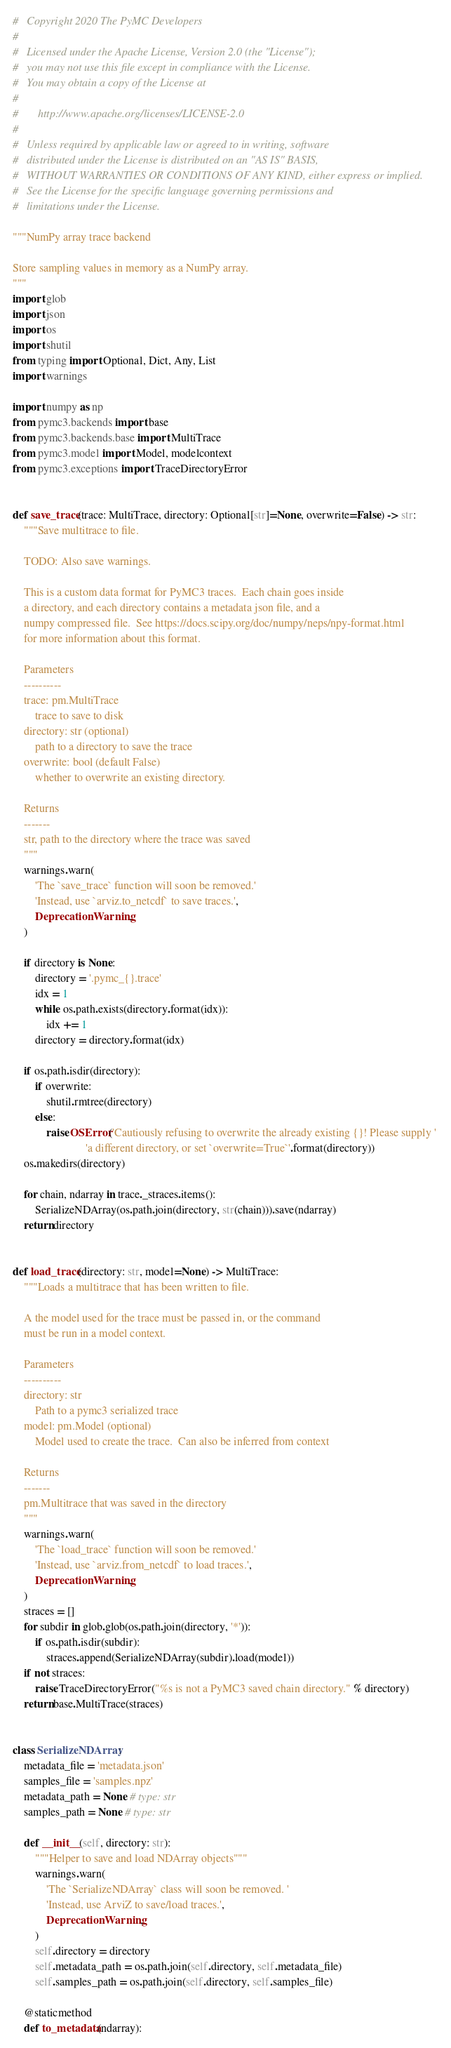Convert code to text. <code><loc_0><loc_0><loc_500><loc_500><_Python_>#   Copyright 2020 The PyMC Developers
#
#   Licensed under the Apache License, Version 2.0 (the "License");
#   you may not use this file except in compliance with the License.
#   You may obtain a copy of the License at
#
#       http://www.apache.org/licenses/LICENSE-2.0
#
#   Unless required by applicable law or agreed to in writing, software
#   distributed under the License is distributed on an "AS IS" BASIS,
#   WITHOUT WARRANTIES OR CONDITIONS OF ANY KIND, either express or implied.
#   See the License for the specific language governing permissions and
#   limitations under the License.

"""NumPy array trace backend

Store sampling values in memory as a NumPy array.
"""
import glob
import json
import os
import shutil
from typing import Optional, Dict, Any, List
import warnings

import numpy as np
from pymc3.backends import base
from pymc3.backends.base import MultiTrace
from pymc3.model import Model, modelcontext
from pymc3.exceptions import TraceDirectoryError


def save_trace(trace: MultiTrace, directory: Optional[str]=None, overwrite=False) -> str:
    """Save multitrace to file.

    TODO: Also save warnings.

    This is a custom data format for PyMC3 traces.  Each chain goes inside
    a directory, and each directory contains a metadata json file, and a
    numpy compressed file.  See https://docs.scipy.org/doc/numpy/neps/npy-format.html
    for more information about this format.

    Parameters
    ----------
    trace: pm.MultiTrace
        trace to save to disk
    directory: str (optional)
        path to a directory to save the trace
    overwrite: bool (default False)
        whether to overwrite an existing directory.

    Returns
    -------
    str, path to the directory where the trace was saved
    """
    warnings.warn(
        'The `save_trace` function will soon be removed.'
        'Instead, use `arviz.to_netcdf` to save traces.',
        DeprecationWarning,
    )

    if directory is None:
        directory = '.pymc_{}.trace'
        idx = 1
        while os.path.exists(directory.format(idx)):
            idx += 1
        directory = directory.format(idx)

    if os.path.isdir(directory):
        if overwrite:
            shutil.rmtree(directory)
        else:
            raise OSError('Cautiously refusing to overwrite the already existing {}! Please supply '
                          'a different directory, or set `overwrite=True`'.format(directory))
    os.makedirs(directory)

    for chain, ndarray in trace._straces.items():
        SerializeNDArray(os.path.join(directory, str(chain))).save(ndarray)
    return directory


def load_trace(directory: str, model=None) -> MultiTrace:
    """Loads a multitrace that has been written to file.

    A the model used for the trace must be passed in, or the command
    must be run in a model context.

    Parameters
    ----------
    directory: str
        Path to a pymc3 serialized trace
    model: pm.Model (optional)
        Model used to create the trace.  Can also be inferred from context

    Returns
    -------
    pm.Multitrace that was saved in the directory
    """
    warnings.warn(
        'The `load_trace` function will soon be removed.'
        'Instead, use `arviz.from_netcdf` to load traces.',
        DeprecationWarning,
    )
    straces = []
    for subdir in glob.glob(os.path.join(directory, '*')):
        if os.path.isdir(subdir):
            straces.append(SerializeNDArray(subdir).load(model))
    if not straces:
        raise TraceDirectoryError("%s is not a PyMC3 saved chain directory." % directory)
    return base.MultiTrace(straces)


class SerializeNDArray:
    metadata_file = 'metadata.json'
    samples_file = 'samples.npz'
    metadata_path = None # type: str
    samples_path = None # type: str

    def __init__(self, directory: str):
        """Helper to save and load NDArray objects"""
        warnings.warn(
            'The `SerializeNDArray` class will soon be removed. '
            'Instead, use ArviZ to save/load traces.',
            DeprecationWarning,
        )
        self.directory = directory
        self.metadata_path = os.path.join(self.directory, self.metadata_file)
        self.samples_path = os.path.join(self.directory, self.samples_file)

    @staticmethod
    def to_metadata(ndarray):</code> 